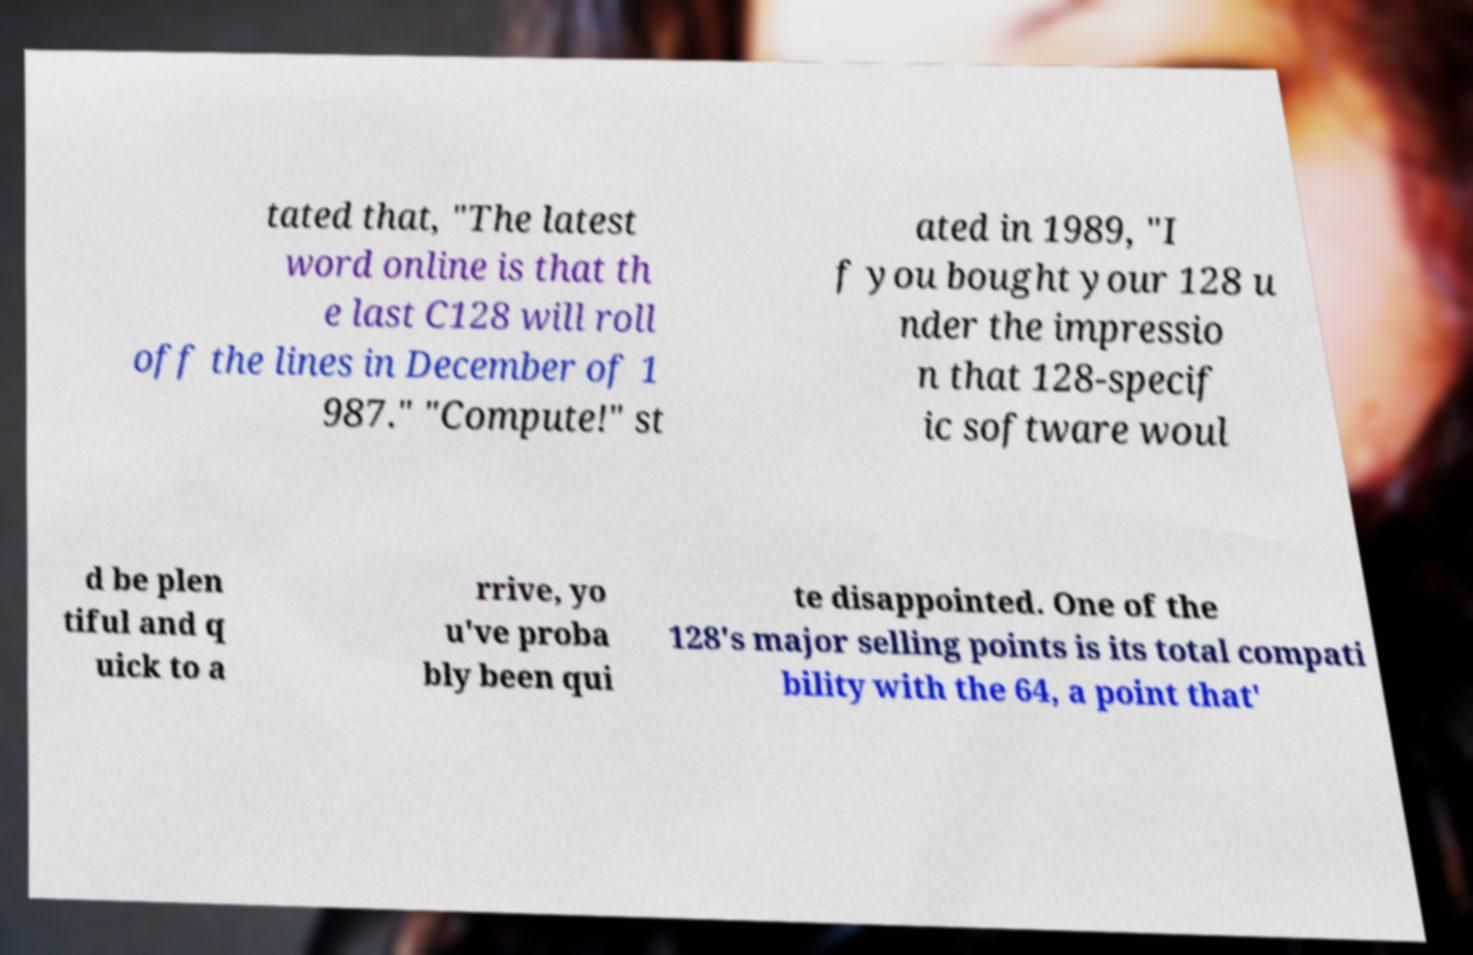Please identify and transcribe the text found in this image. tated that, "The latest word online is that th e last C128 will roll off the lines in December of 1 987." "Compute!" st ated in 1989, "I f you bought your 128 u nder the impressio n that 128-specif ic software woul d be plen tiful and q uick to a rrive, yo u've proba bly been qui te disappointed. One of the 128's major selling points is its total compati bility with the 64, a point that' 